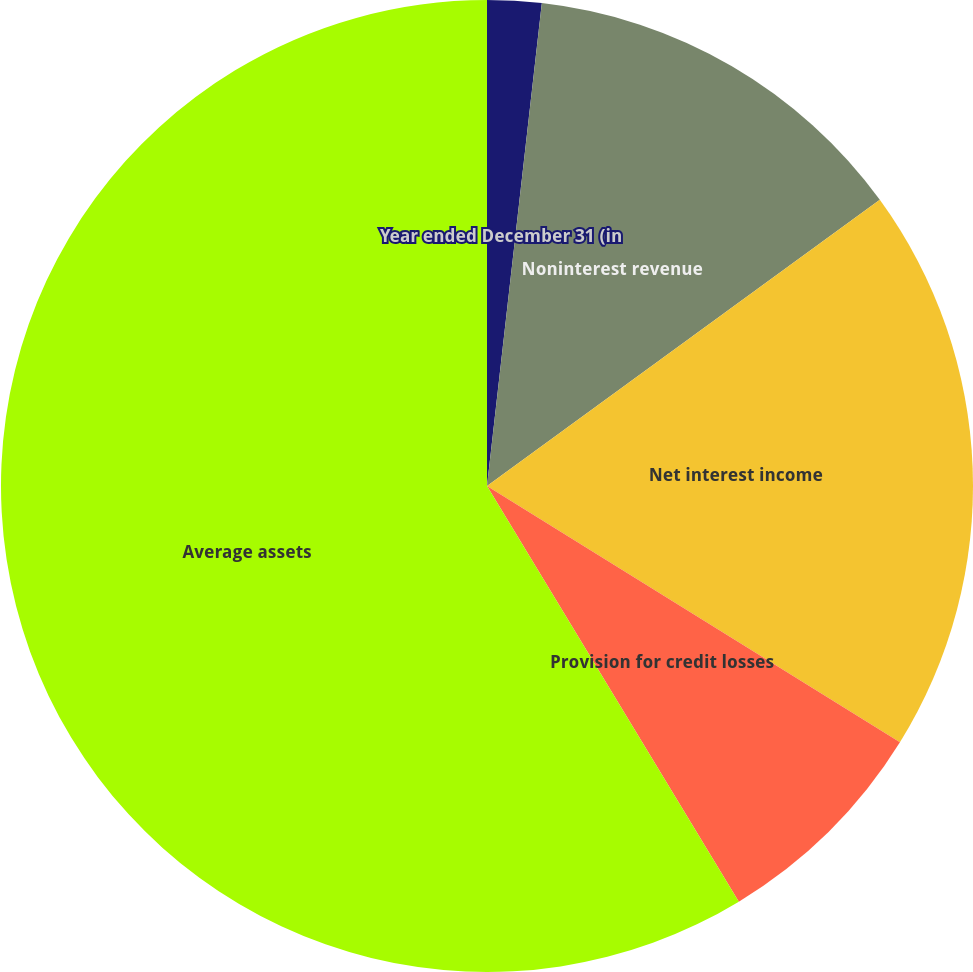Convert chart. <chart><loc_0><loc_0><loc_500><loc_500><pie_chart><fcel>Year ended December 31 (in<fcel>Noninterest revenue<fcel>Net interest income<fcel>Provision for credit losses<fcel>Average assets<nl><fcel>1.8%<fcel>13.18%<fcel>18.86%<fcel>7.49%<fcel>58.67%<nl></chart> 